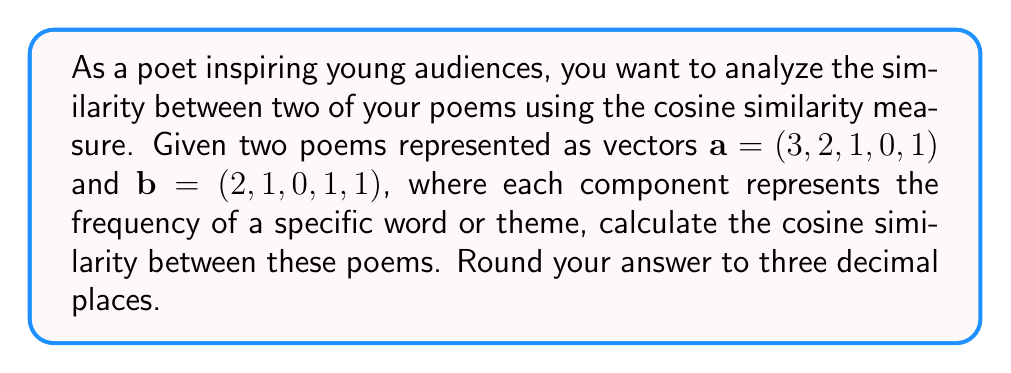Can you answer this question? To compute the cosine similarity between two vectors, we use the formula:

$$\text{cosine similarity} = \frac{\mathbf{a} \cdot \mathbf{b}}{\|\mathbf{a}\| \|\mathbf{b}\|}$$

Where $\mathbf{a} \cdot \mathbf{b}$ is the dot product of the vectors, and $\|\mathbf{a}\|$ and $\|\mathbf{b}\|$ are the magnitudes of vectors $\mathbf{a}$ and $\mathbf{b}$ respectively.

Step 1: Calculate the dot product $\mathbf{a} \cdot \mathbf{b}$
$$\mathbf{a} \cdot \mathbf{b} = (3 \times 2) + (2 \times 1) + (1 \times 0) + (0 \times 1) + (1 \times 1) = 6 + 2 + 0 + 0 + 1 = 9$$

Step 2: Calculate the magnitude of vector $\mathbf{a}$
$$\|\mathbf{a}\| = \sqrt{3^2 + 2^2 + 1^2 + 0^2 + 1^2} = \sqrt{9 + 4 + 1 + 0 + 1} = \sqrt{15}$$

Step 3: Calculate the magnitude of vector $\mathbf{b}$
$$\|\mathbf{b}\| = \sqrt{2^2 + 1^2 + 0^2 + 1^2 + 1^2} = \sqrt{4 + 1 + 0 + 1 + 1} = \sqrt{7}$$

Step 4: Apply the cosine similarity formula
$$\text{cosine similarity} = \frac{9}{\sqrt{15} \times \sqrt{7}} = \frac{9}{\sqrt{105}} \approx 0.878$$

Rounding to three decimal places, we get 0.878.
Answer: 0.878 